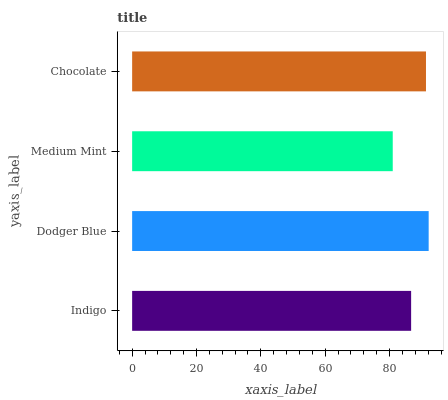Is Medium Mint the minimum?
Answer yes or no. Yes. Is Dodger Blue the maximum?
Answer yes or no. Yes. Is Dodger Blue the minimum?
Answer yes or no. No. Is Medium Mint the maximum?
Answer yes or no. No. Is Dodger Blue greater than Medium Mint?
Answer yes or no. Yes. Is Medium Mint less than Dodger Blue?
Answer yes or no. Yes. Is Medium Mint greater than Dodger Blue?
Answer yes or no. No. Is Dodger Blue less than Medium Mint?
Answer yes or no. No. Is Chocolate the high median?
Answer yes or no. Yes. Is Indigo the low median?
Answer yes or no. Yes. Is Medium Mint the high median?
Answer yes or no. No. Is Medium Mint the low median?
Answer yes or no. No. 